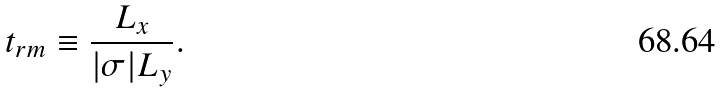Convert formula to latex. <formula><loc_0><loc_0><loc_500><loc_500>t _ { r m } \equiv \frac { L _ { x } } { | \sigma | L _ { y } } .</formula> 